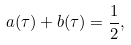<formula> <loc_0><loc_0><loc_500><loc_500>a ( \tau ) + b ( \tau ) = \frac { 1 } { 2 } ,</formula> 